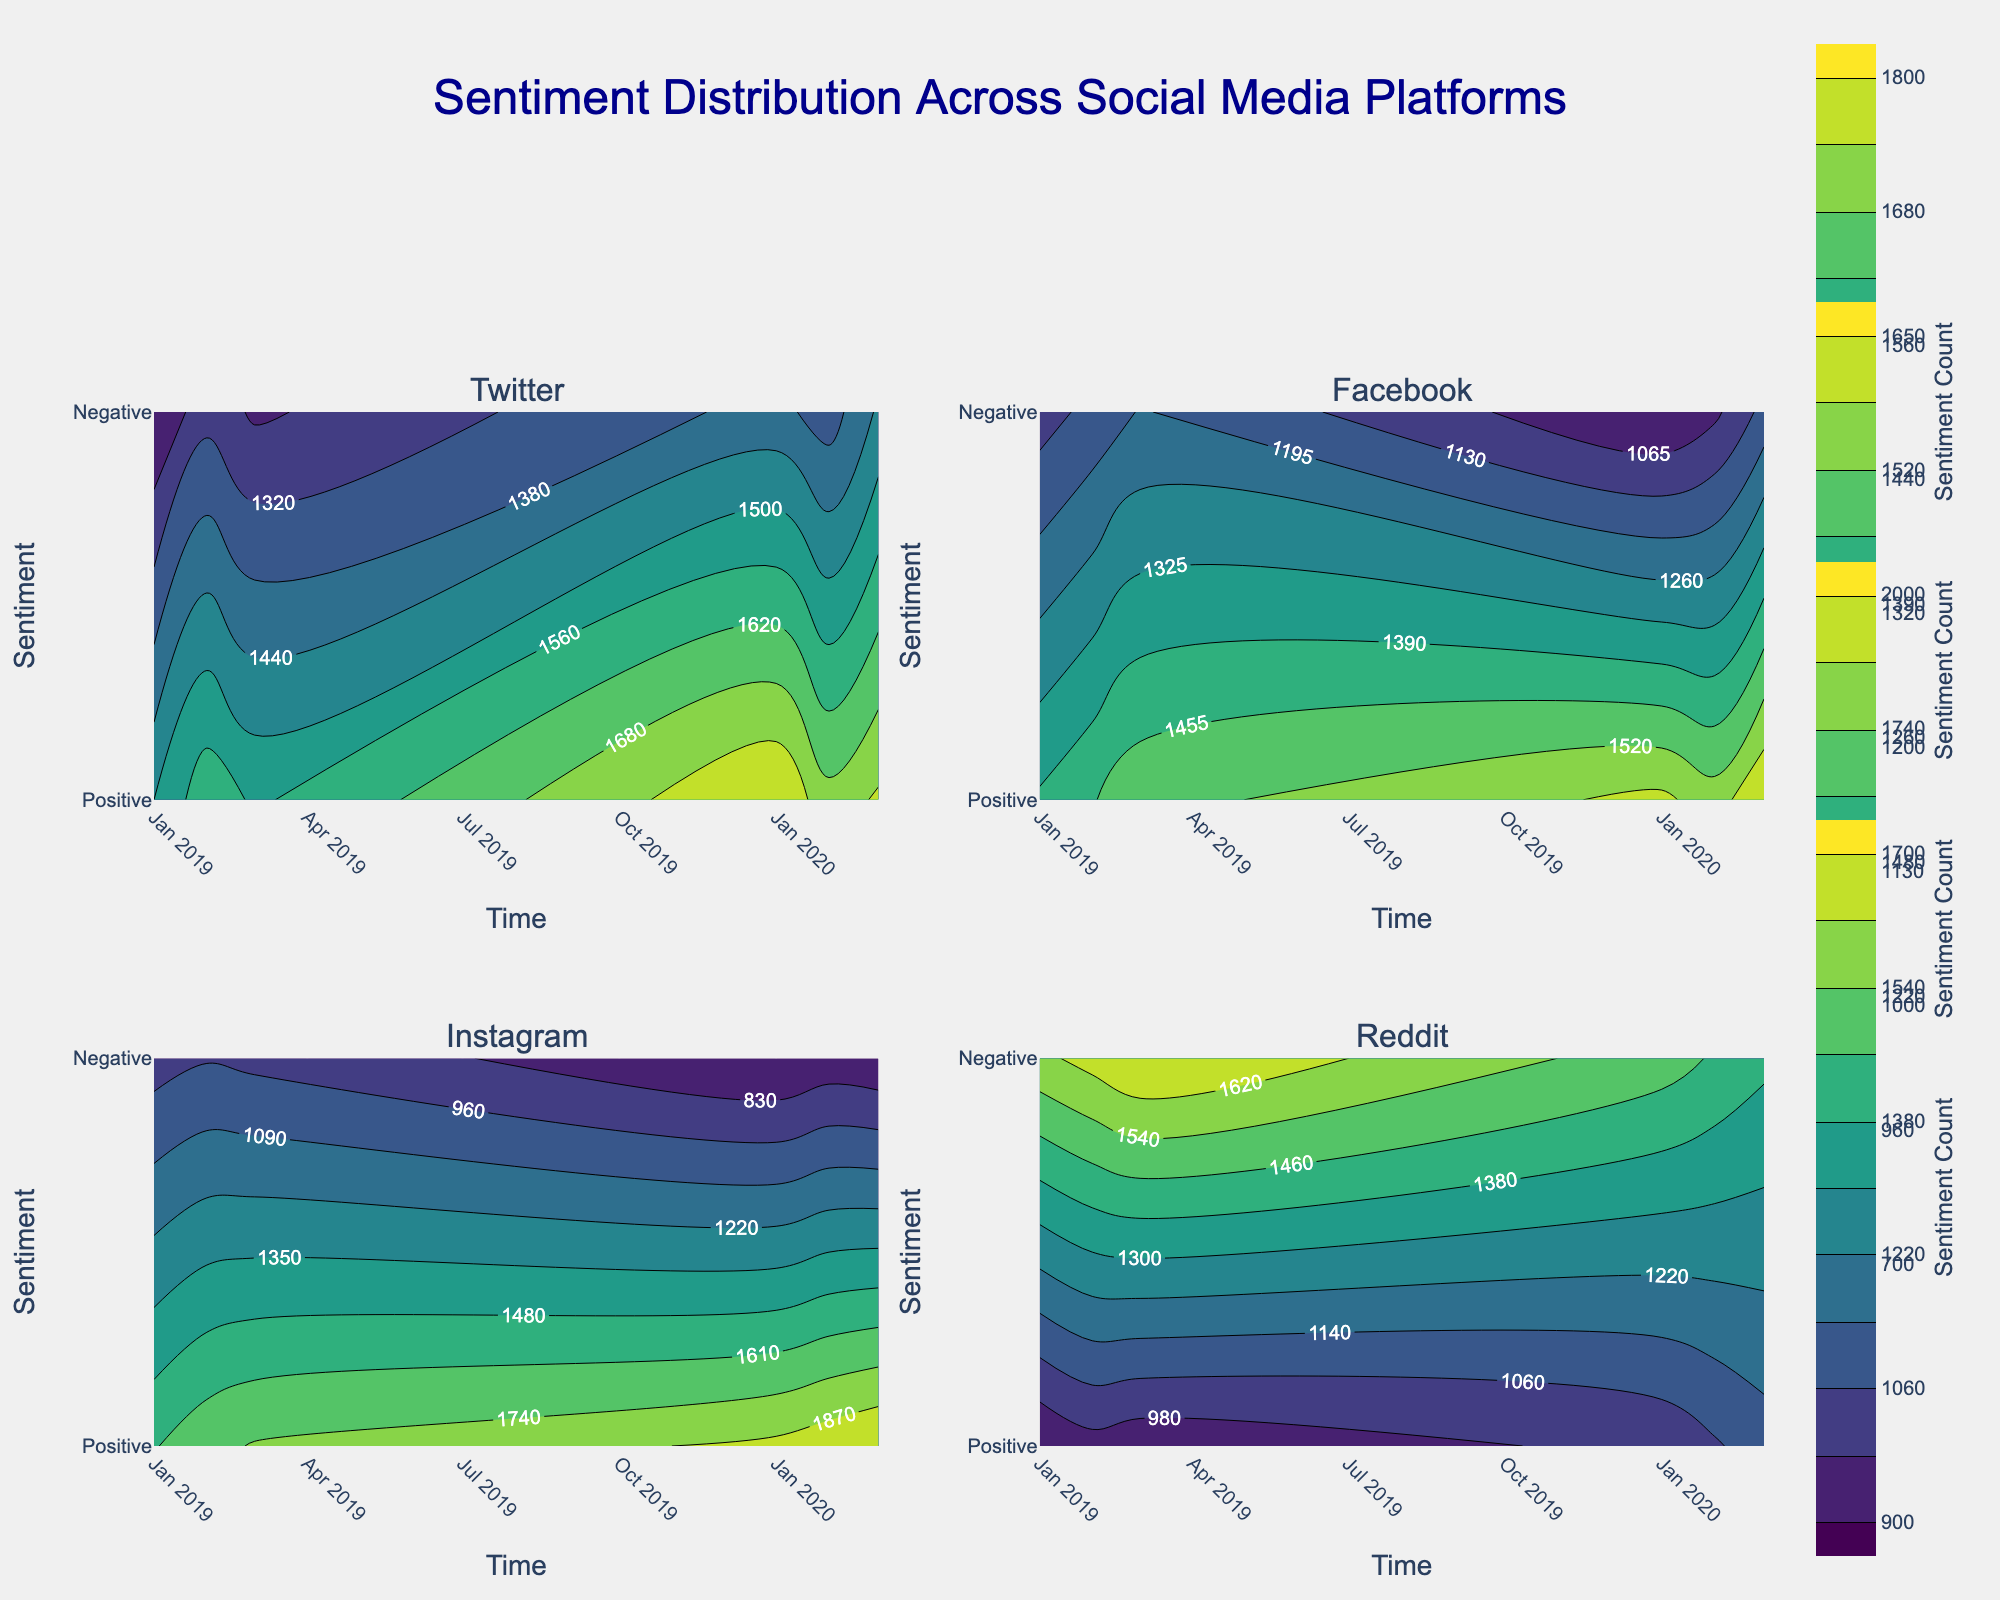What is the title of the figure? The title is located at the top of the figure, centered and written in a dark blue font. It reads "Sentiment Distribution Across Social Media Platforms."
Answer: "Sentiment Distribution Across Social Media Platforms" Which social media platform shows the highest positive sentiment in March 2020? Across the different platforms' subplots, Instagram has the highest positive sentiment value in March 2020. This can be discerned by observing the peak darkest/sharpest contour line associated with the positive sentiment in March 2020.
Answer: Instagram How does the negative sentiment trend on Reddit from January 2019 to March 2020? In Reddit's subplot, if we follow the contour for negative sentiment from January 2019 to March 2020, we notice a gradual decrease in negativity. This is depicted through a shift from higher negative sentiment values to lower ones over time.
Answer: Decreasing Compare the positive sentiment of Twitter in January 2019 and March 2020. Which one is higher? By checking Twitter's subplot, the positive sentiment value in March 2020 is higher than in January 2019. This is evident from the contour lines showing increased sentiment between these two dates.
Answer: March 2020 Which platform shows a more significant drop in negative sentiment from 2019 to 2020, Facebook or Instagram? By analyzing the contours for negative sentiment on both Facebook and Instagram subplots from 2019 to 2020, Instagram shows a more significant drop in its negative sentiment values. The smallest values in Instagram's contour plot indicate a steeper decrease compared to the gradual change in Facebook's plot.
Answer: Instagram Between January 2019 and December 2020, which platform shows the least change in positive sentiment? Looking at the contours for the positive sentiment across all platforms, Reddit shows the least change, with the contour lines for positive sentiment remaining relatively stable over the period compared to other platforms.
Answer: Reddit What trend can be observed in Facebook's positive sentiment from January 2019 to March 2020? In Facebook's subplot, the positive sentiment trend shows an increase from January 2019 to March 2020, which can be inferred from the contours becoming denser and peaking towards the latter date.
Answer: Increasing What is the color scheme used for the contour plots, and what does it represent? The color scheme used in the figure is Viridis, which ranges from dark purple to light yellow. In this context, it represents the range of sentiment counts, with the darkest colors indicating lower values and the lightest colors indicating higher values.
Answer: Viridis, indicating sentiment counts Which platform had the highest negative sentiment in early 2019, and has this trend changed by March 2020? By comparing the contours for negative sentiment in early 2019, Reddit had the highest negative sentiment. However, by March 2020, this trend has changed, with Reddit's negative sentiment decreasing and other platforms like Twitter showing higher negativity levels.
Answer: Reddit, changed 